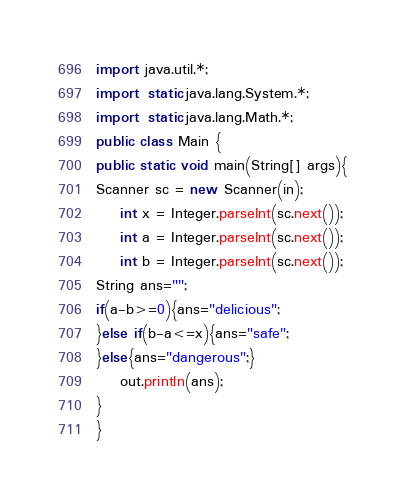Convert code to text. <code><loc_0><loc_0><loc_500><loc_500><_Java_>import java.util.*;
import static java.lang.System.*;
import static java.lang.Math.*;
public class Main {
public static void main(String[] args){
Scanner sc = new Scanner(in);
    int x = Integer.parseInt(sc.next());
    int a = Integer.parseInt(sc.next());
    int b = Integer.parseInt(sc.next());
String ans="";
if(a-b>=0){ans="delicious";
}else if(b-a<=x){ans="safe";
}else{ans="dangerous";}
    out.println(ans);
}
}</code> 